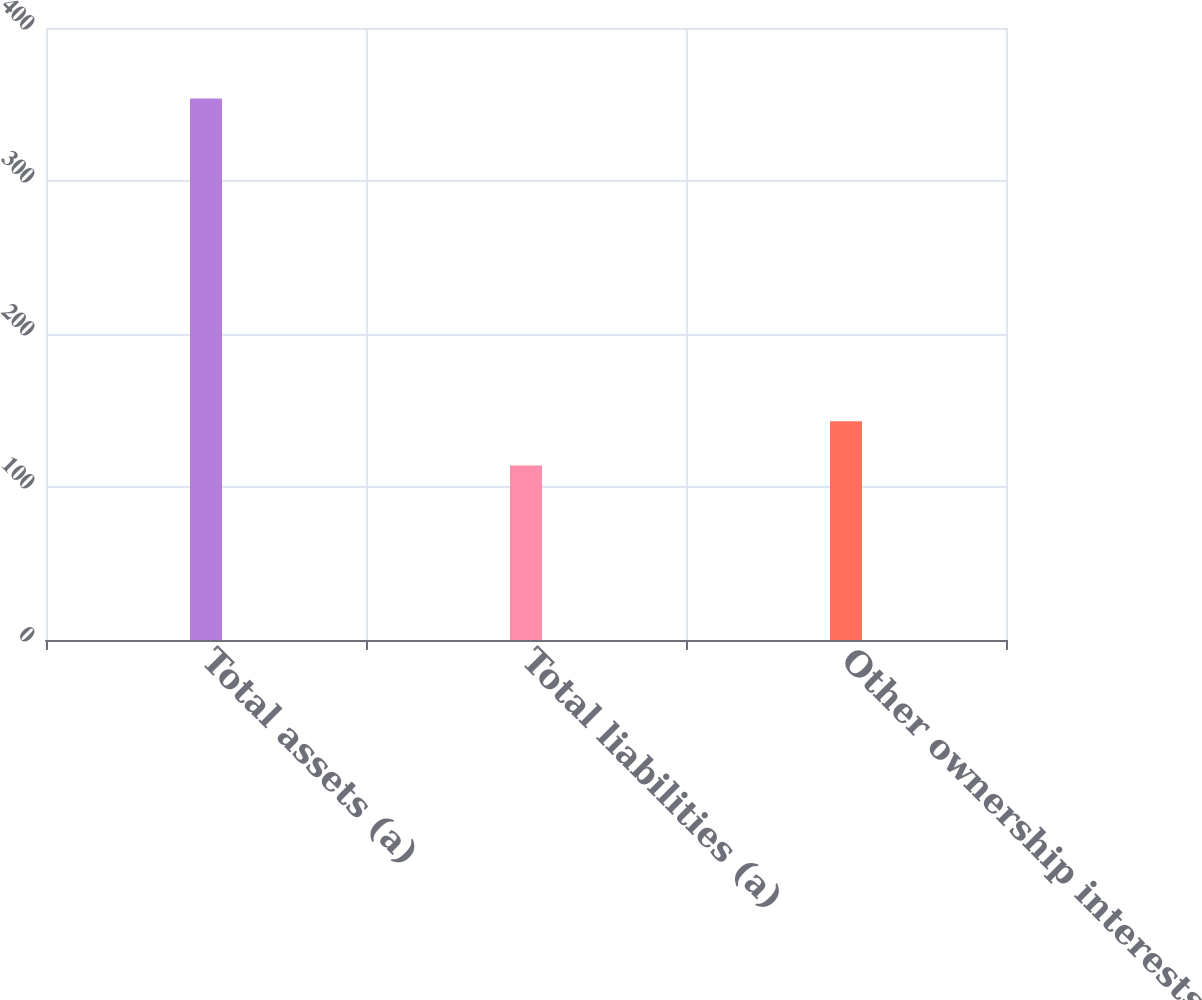<chart> <loc_0><loc_0><loc_500><loc_500><bar_chart><fcel>Total assets (a)<fcel>Total liabilities (a)<fcel>Other ownership interests (a)<nl><fcel>354<fcel>114<fcel>143<nl></chart> 